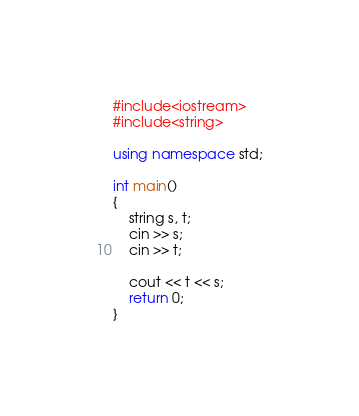<code> <loc_0><loc_0><loc_500><loc_500><_C++_>#include<iostream>
#include<string>

using namespace std;

int main()
{
	string s, t;
	cin >> s;
	cin >> t;

	cout << t << s;
	return 0;
}</code> 